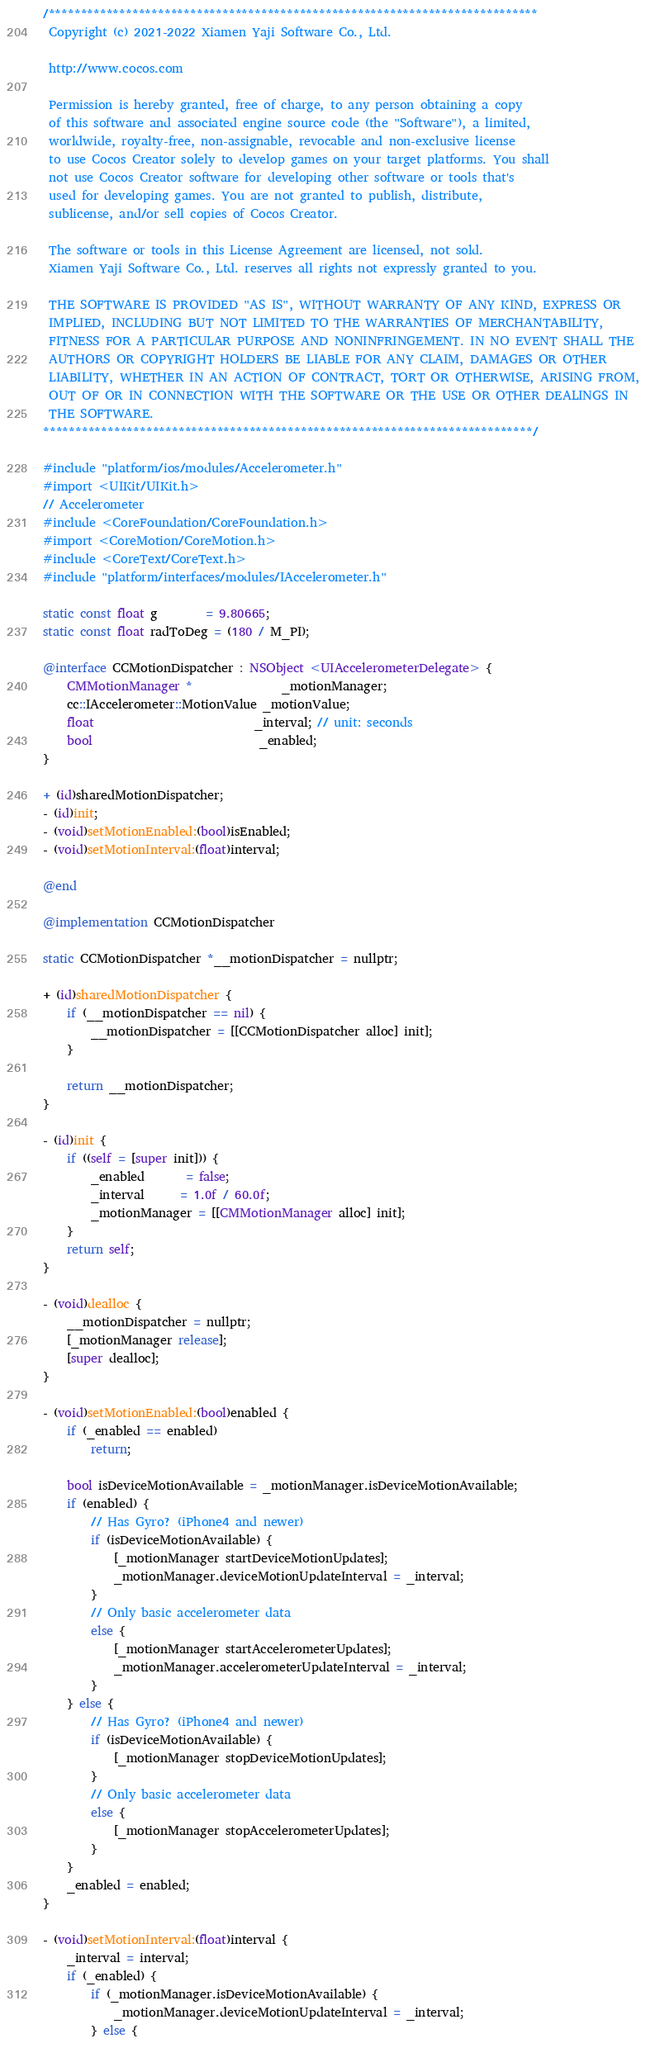Convert code to text. <code><loc_0><loc_0><loc_500><loc_500><_ObjectiveC_>/****************************************************************************
 Copyright (c) 2021-2022 Xiamen Yaji Software Co., Ltd.

 http://www.cocos.com

 Permission is hereby granted, free of charge, to any person obtaining a copy
 of this software and associated engine source code (the "Software"), a limited,
 worldwide, royalty-free, non-assignable, revocable and non-exclusive license
 to use Cocos Creator solely to develop games on your target platforms. You shall
 not use Cocos Creator software for developing other software or tools that's
 used for developing games. You are not granted to publish, distribute,
 sublicense, and/or sell copies of Cocos Creator.

 The software or tools in this License Agreement are licensed, not sold.
 Xiamen Yaji Software Co., Ltd. reserves all rights not expressly granted to you.

 THE SOFTWARE IS PROVIDED "AS IS", WITHOUT WARRANTY OF ANY KIND, EXPRESS OR
 IMPLIED, INCLUDING BUT NOT LIMITED TO THE WARRANTIES OF MERCHANTABILITY,
 FITNESS FOR A PARTICULAR PURPOSE AND NONINFRINGEMENT. IN NO EVENT SHALL THE
 AUTHORS OR COPYRIGHT HOLDERS BE LIABLE FOR ANY CLAIM, DAMAGES OR OTHER
 LIABILITY, WHETHER IN AN ACTION OF CONTRACT, TORT OR OTHERWISE, ARISING FROM,
 OUT OF OR IN CONNECTION WITH THE SOFTWARE OR THE USE OR OTHER DEALINGS IN
 THE SOFTWARE.
****************************************************************************/

#include "platform/ios/modules/Accelerometer.h"
#import <UIKit/UIKit.h>
// Accelerometer
#include <CoreFoundation/CoreFoundation.h>
#import <CoreMotion/CoreMotion.h>
#include <CoreText/CoreText.h>
#include "platform/interfaces/modules/IAccelerometer.h"

static const float g        = 9.80665;
static const float radToDeg = (180 / M_PI);

@interface CCMotionDispatcher : NSObject <UIAccelerometerDelegate> {
    CMMotionManager *               _motionManager;
    cc::IAccelerometer::MotionValue _motionValue;
    float                           _interval; // unit: seconds
    bool                            _enabled;
}

+ (id)sharedMotionDispatcher;
- (id)init;
- (void)setMotionEnabled:(bool)isEnabled;
- (void)setMotionInterval:(float)interval;

@end

@implementation CCMotionDispatcher

static CCMotionDispatcher *__motionDispatcher = nullptr;

+ (id)sharedMotionDispatcher {
    if (__motionDispatcher == nil) {
        __motionDispatcher = [[CCMotionDispatcher alloc] init];
    }

    return __motionDispatcher;
}

- (id)init {
    if ((self = [super init])) {
        _enabled       = false;
        _interval      = 1.0f / 60.0f;
        _motionManager = [[CMMotionManager alloc] init];
    }
    return self;
}

- (void)dealloc {
    __motionDispatcher = nullptr;
    [_motionManager release];
    [super dealloc];
}

- (void)setMotionEnabled:(bool)enabled {
    if (_enabled == enabled)
        return;

    bool isDeviceMotionAvailable = _motionManager.isDeviceMotionAvailable;
    if (enabled) {
        // Has Gyro? (iPhone4 and newer)
        if (isDeviceMotionAvailable) {
            [_motionManager startDeviceMotionUpdates];
            _motionManager.deviceMotionUpdateInterval = _interval;
        }
        // Only basic accelerometer data
        else {
            [_motionManager startAccelerometerUpdates];
            _motionManager.accelerometerUpdateInterval = _interval;
        }
    } else {
        // Has Gyro? (iPhone4 and newer)
        if (isDeviceMotionAvailable) {
            [_motionManager stopDeviceMotionUpdates];
        }
        // Only basic accelerometer data
        else {
            [_motionManager stopAccelerometerUpdates];
        }
    }
    _enabled = enabled;
}

- (void)setMotionInterval:(float)interval {
    _interval = interval;
    if (_enabled) {
        if (_motionManager.isDeviceMotionAvailable) {
            _motionManager.deviceMotionUpdateInterval = _interval;
        } else {</code> 